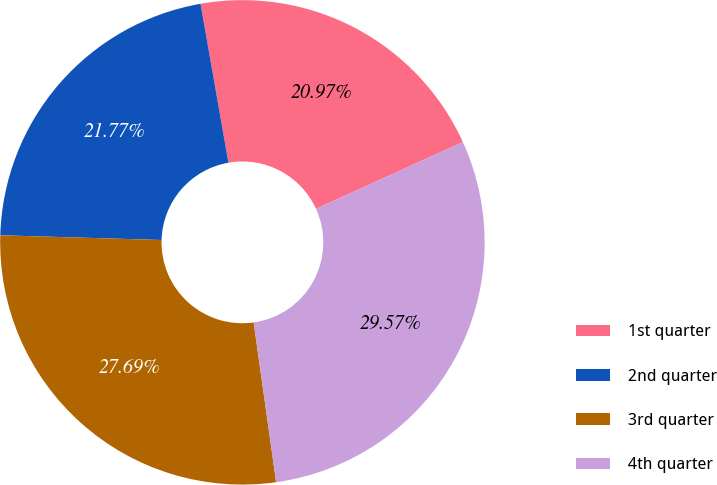Convert chart. <chart><loc_0><loc_0><loc_500><loc_500><pie_chart><fcel>1st quarter<fcel>2nd quarter<fcel>3rd quarter<fcel>4th quarter<nl><fcel>20.97%<fcel>21.77%<fcel>27.69%<fcel>29.57%<nl></chart> 